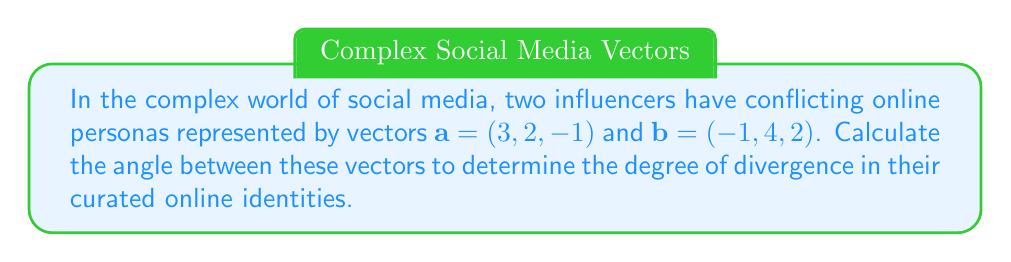Can you solve this math problem? To find the angle between two vectors, we'll use the dot product formula:

$$\cos \theta = \frac{\mathbf{a} \cdot \mathbf{b}}{|\mathbf{a}| |\mathbf{b}|}$$

Step 1: Calculate the dot product $\mathbf{a} \cdot \mathbf{b}$
$$\mathbf{a} \cdot \mathbf{b} = (3)(-1) + (2)(4) + (-1)(2) = -3 + 8 - 2 = 3$$

Step 2: Calculate the magnitudes of vectors $\mathbf{a}$ and $\mathbf{b}$
$$|\mathbf{a}| = \sqrt{3^2 + 2^2 + (-1)^2} = \sqrt{9 + 4 + 1} = \sqrt{14}$$
$$|\mathbf{b}| = \sqrt{(-1)^2 + 4^2 + 2^2} = \sqrt{1 + 16 + 4} = \sqrt{21}$$

Step 3: Substitute into the formula
$$\cos \theta = \frac{3}{\sqrt{14} \sqrt{21}}$$

Step 4: Simplify
$$\cos \theta = \frac{3}{\sqrt{294}}$$

Step 5: Take the inverse cosine (arccos) of both sides
$$\theta = \arccos\left(\frac{3}{\sqrt{294}}\right)$$

Step 6: Calculate the result (rounded to two decimal places)
$$\theta \approx 1.39 \text{ radians} \approx 79.61°$$
Answer: $79.61°$ 